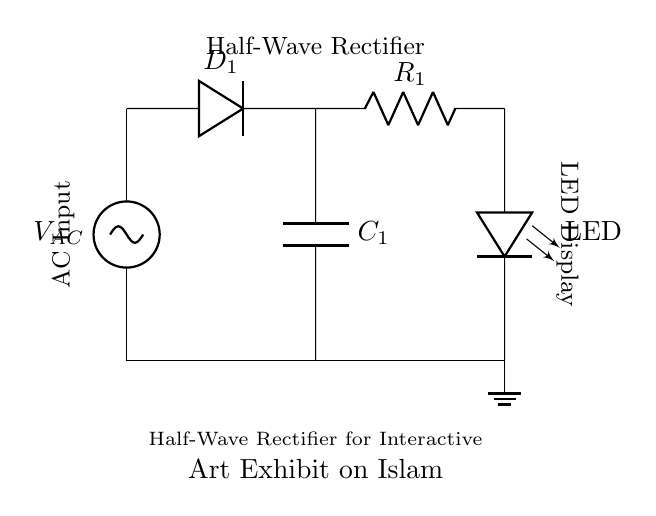What is the type of AC source in this circuit? The circuit includes a standard AC voltage source, which is represented as VAC. It is located at the left side of the diagram as indicated.
Answer: AC voltage What component converts AC to DC in this circuit? The diode, labeled D1 in the circuit, is responsible for allowing current to flow in only one direction, effectively converting AC to DC. This is indicated by its placement after the AC source.
Answer: Diode What is the function of the capacitor in this circuit? The capacitor, noted as C1, acts to smooth the output voltage after rectification. It charges during the peak of the AC cycle and discharges to provide a more stable DC voltage. This is indicated as it connects to both the diode and the ground.
Answer: Smoothing How many resistors are present in this circuit? The circuit contains one resistor, labeled R1. It is in series with the LED and helps to control the current flowing through the LED. Its presence is indicated in the path leading from the diode to the LED.
Answer: One What does LED stand for in this circuit? The LED denotes a light-emitting diode, which illuminates when current passes through it. In the context of this circuit, it directly connects to the output of the rectifier.
Answer: Light-emitting diode What does the circuit illustrate underneath its title? The title indicates that this is a half-wave rectifier designed for an interactive art exhibit that explores misconceptions about Islam, showing its educational purpose in the context of Islamic art.
Answer: Half-wave rectifier for interactive art exhibit What is the overall output characteristic of this rectifier circuit? This circuit provides a unidirectional current supply since it is a half-wave rectifier, which means that only one half of the AC waveform contributes to the output DC. This characteristic is fundamental to its operation as a rectifier.
Answer: Unidirectional current supply 